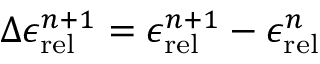<formula> <loc_0><loc_0><loc_500><loc_500>\Delta \epsilon _ { r e l } ^ { n + 1 } = \epsilon _ { r e l } ^ { n + 1 } - \epsilon _ { r e l } ^ { n }</formula> 